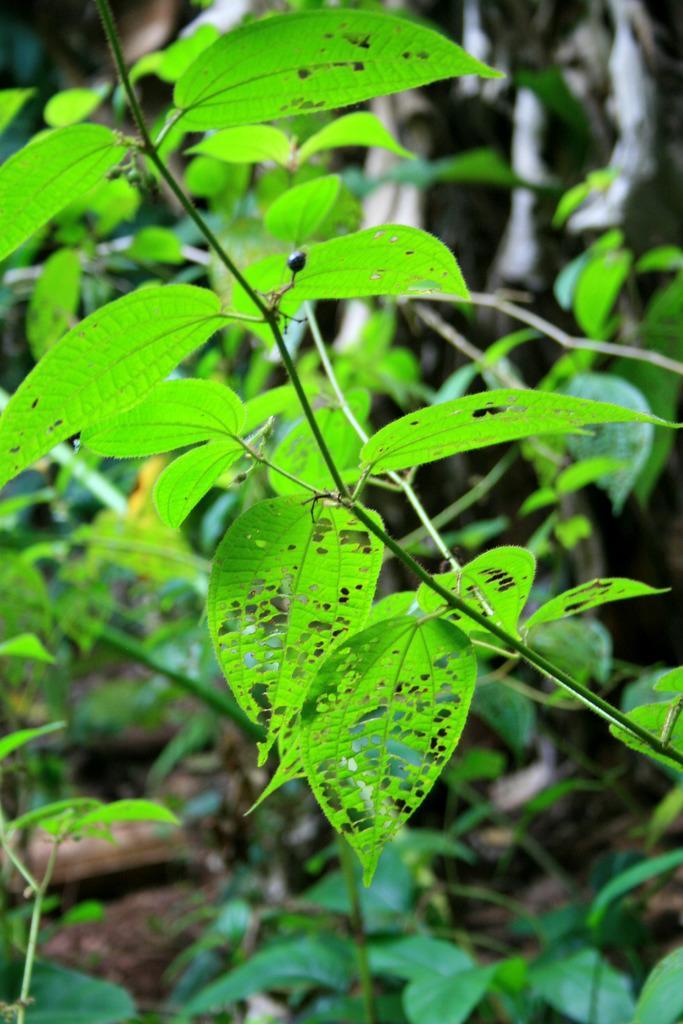Could you give a brief overview of what you see in this image? In this image there are plants. There are leaves to the stems. In the center there are damaged leaves. 